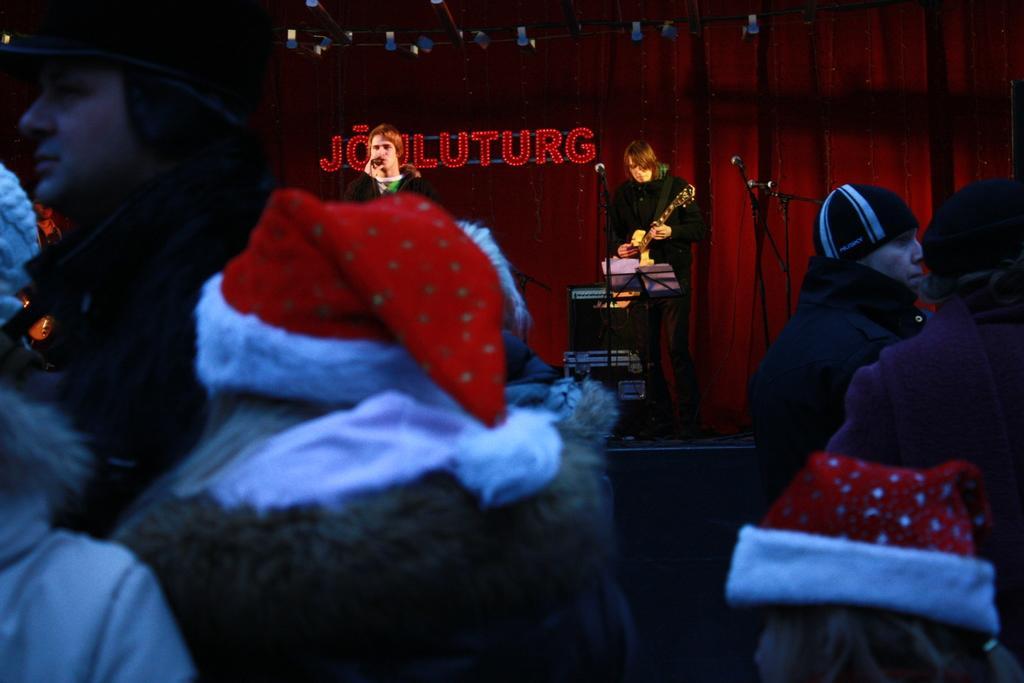Can you describe this image briefly? In this image we can see few people wearing caps. In the back there is a person holding mic. Also there is a person playing guitar. There are mics with mic stands. In the background there is curtain. Also something is written with lights. 